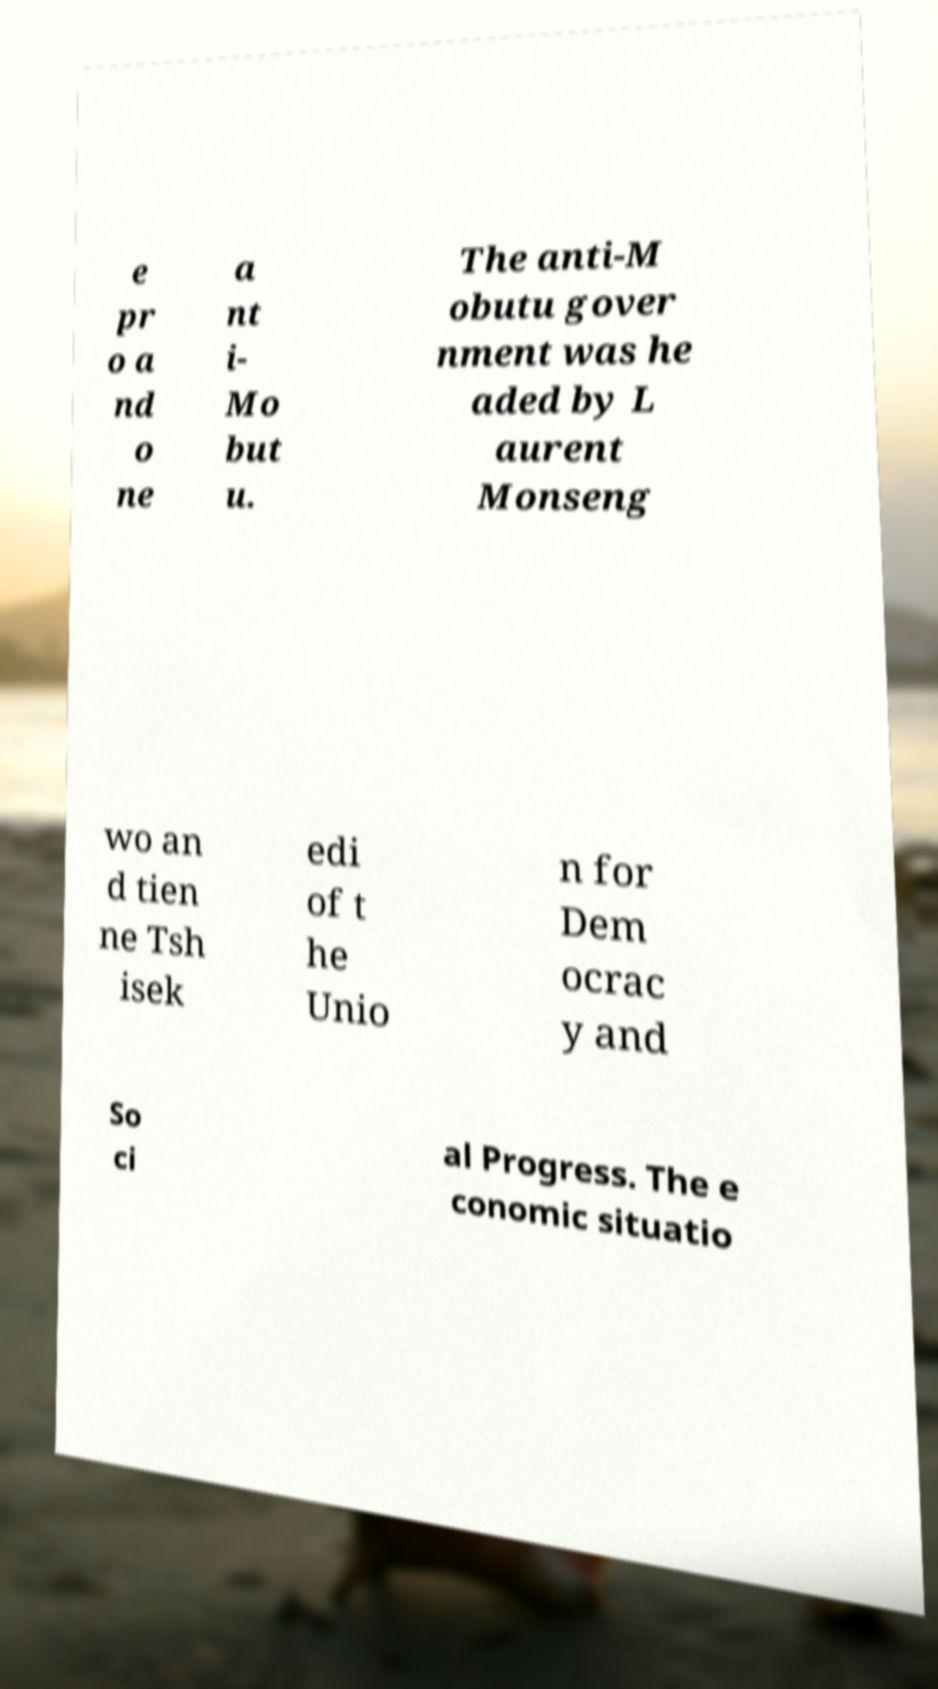Please read and relay the text visible in this image. What does it say? e pr o a nd o ne a nt i- Mo but u. The anti-M obutu gover nment was he aded by L aurent Monseng wo an d tien ne Tsh isek edi of t he Unio n for Dem ocrac y and So ci al Progress. The e conomic situatio 